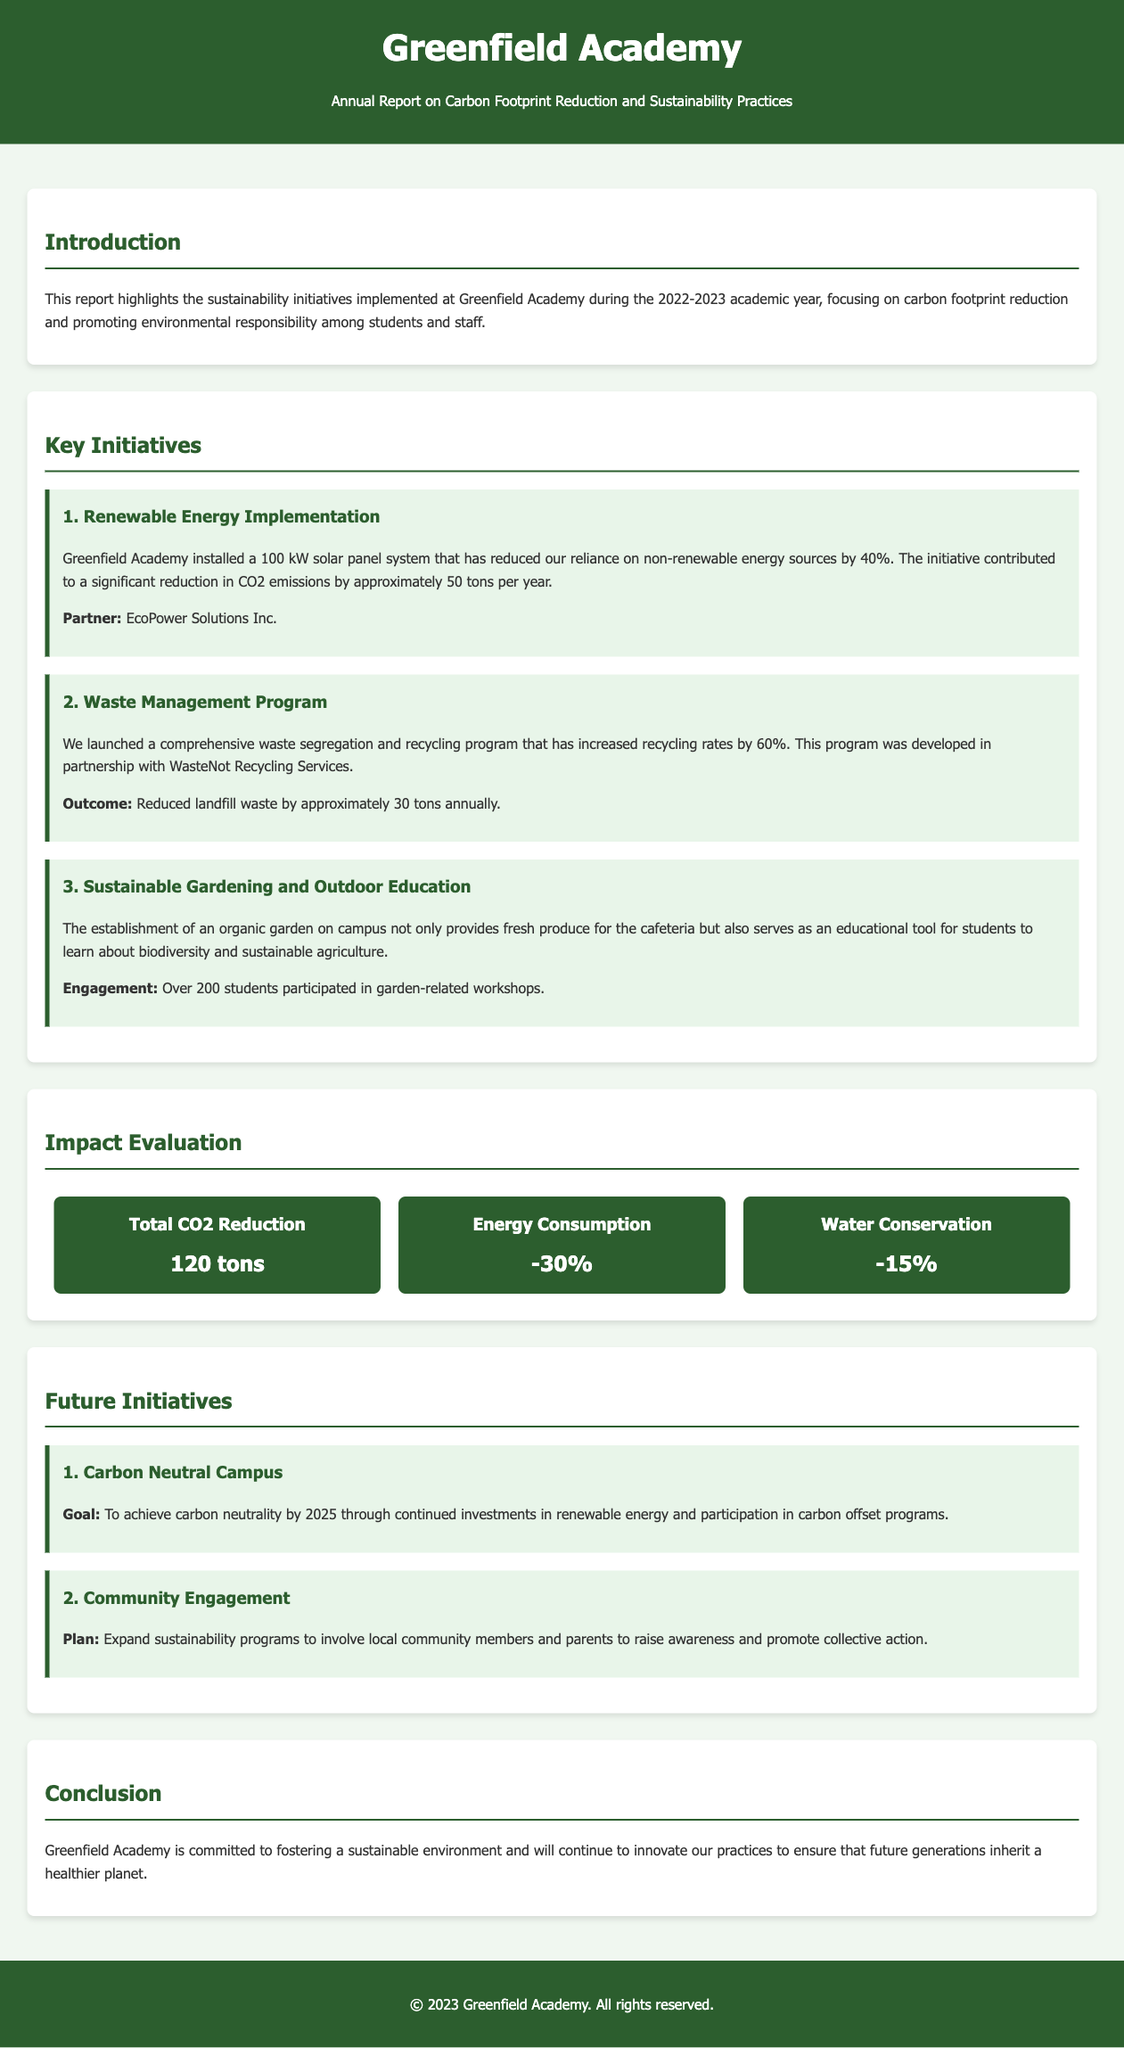What is the name of the school? The name of the school is mentioned in the header of the document.
Answer: Greenfield Academy What year does the report cover? The report indicates the specific academic year it covers in the introduction section.
Answer: 2022-2023 How much CO2 reduction was achieved? CO2 reduction data is presented in the impact evaluation section.
Answer: 120 tons What is the reduction percentage in energy consumption? The energy consumption reduction percentage is listed among the impact statistics.
Answer: -30% Which partner was involved in the Renewable Energy Implementation initiative? The document specifies the partner organization for the renewable energy project in the key initiatives section.
Answer: EcoPower Solutions Inc What is the goal for the Carbon Neutral Campus initiative? The document outlines the goal for achieving carbon neutrality in the future initiatives section.
Answer: To achieve carbon neutrality by 2025 How many students participated in garden-related workshops? The number of students engaged in the gardening initiative is mentioned in the key initiatives section.
Answer: Over 200 students What was the outcome of the Waste Management Program? The specific outcome of the waste management initiative is stated in the key initiatives section.
Answer: Reduced landfill waste by approximately 30 tons annually What is the future plan for community engagement? The future initiatives section discusses the expansion plan for community engagement.
Answer: Expand sustainability programs to involve local community members and parents 